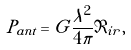Convert formula to latex. <formula><loc_0><loc_0><loc_500><loc_500>P _ { a n t } = G \frac { \lambda ^ { 2 } } { 4 \pi } \Im _ { i r } ,</formula> 